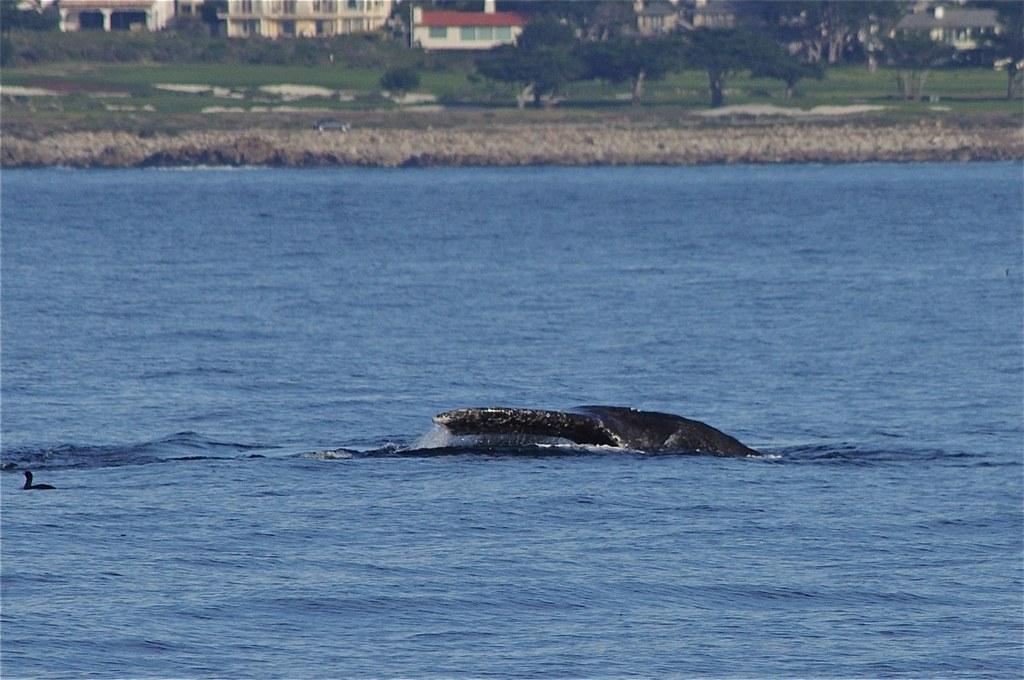What type of animals can be seen in the water in the image? There are fish in the water in the image. What type of bird is on the left side of the image? There is a duck on the left side of the image. What can be seen in the background of the image? There are buildings, trees, plants, and grass in the background of the image. What type of writing can be seen on the duck's back in the image? There is no writing visible on the duck's back in the image. Can you see a robin eating popcorn in the image? There is no robin or popcorn present in the image. 